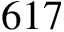<formula> <loc_0><loc_0><loc_500><loc_500>6 1 7</formula> 